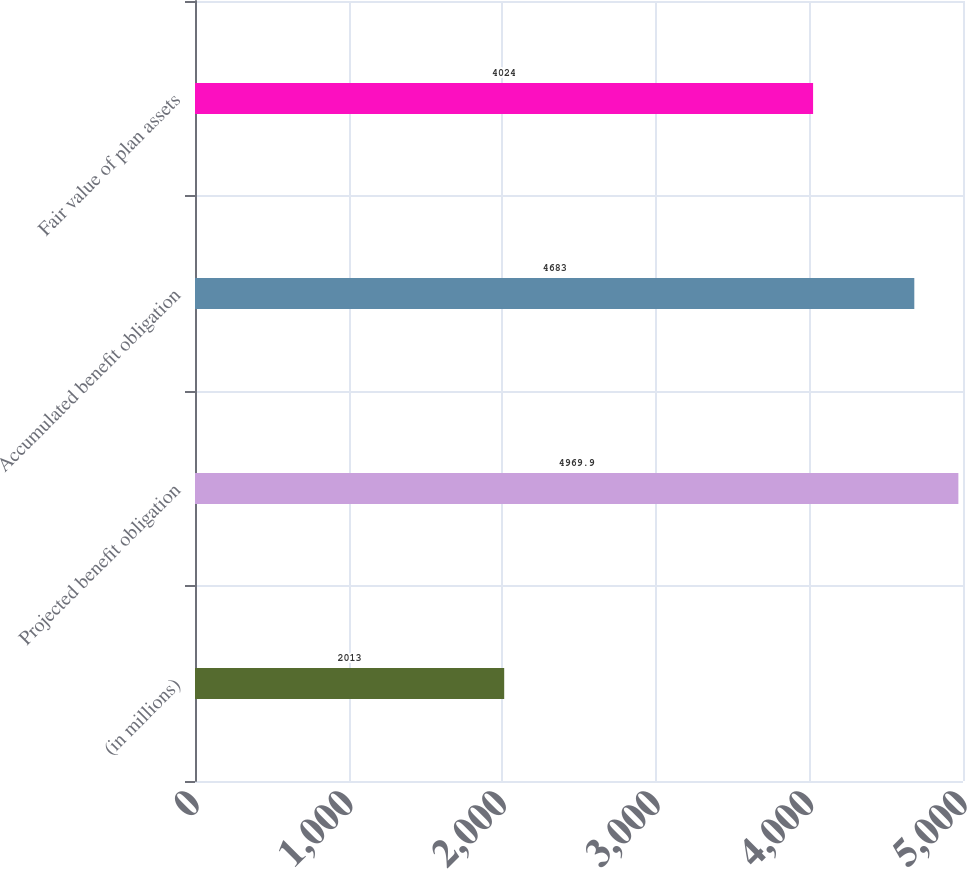Convert chart to OTSL. <chart><loc_0><loc_0><loc_500><loc_500><bar_chart><fcel>(in millions)<fcel>Projected benefit obligation<fcel>Accumulated benefit obligation<fcel>Fair value of plan assets<nl><fcel>2013<fcel>4969.9<fcel>4683<fcel>4024<nl></chart> 